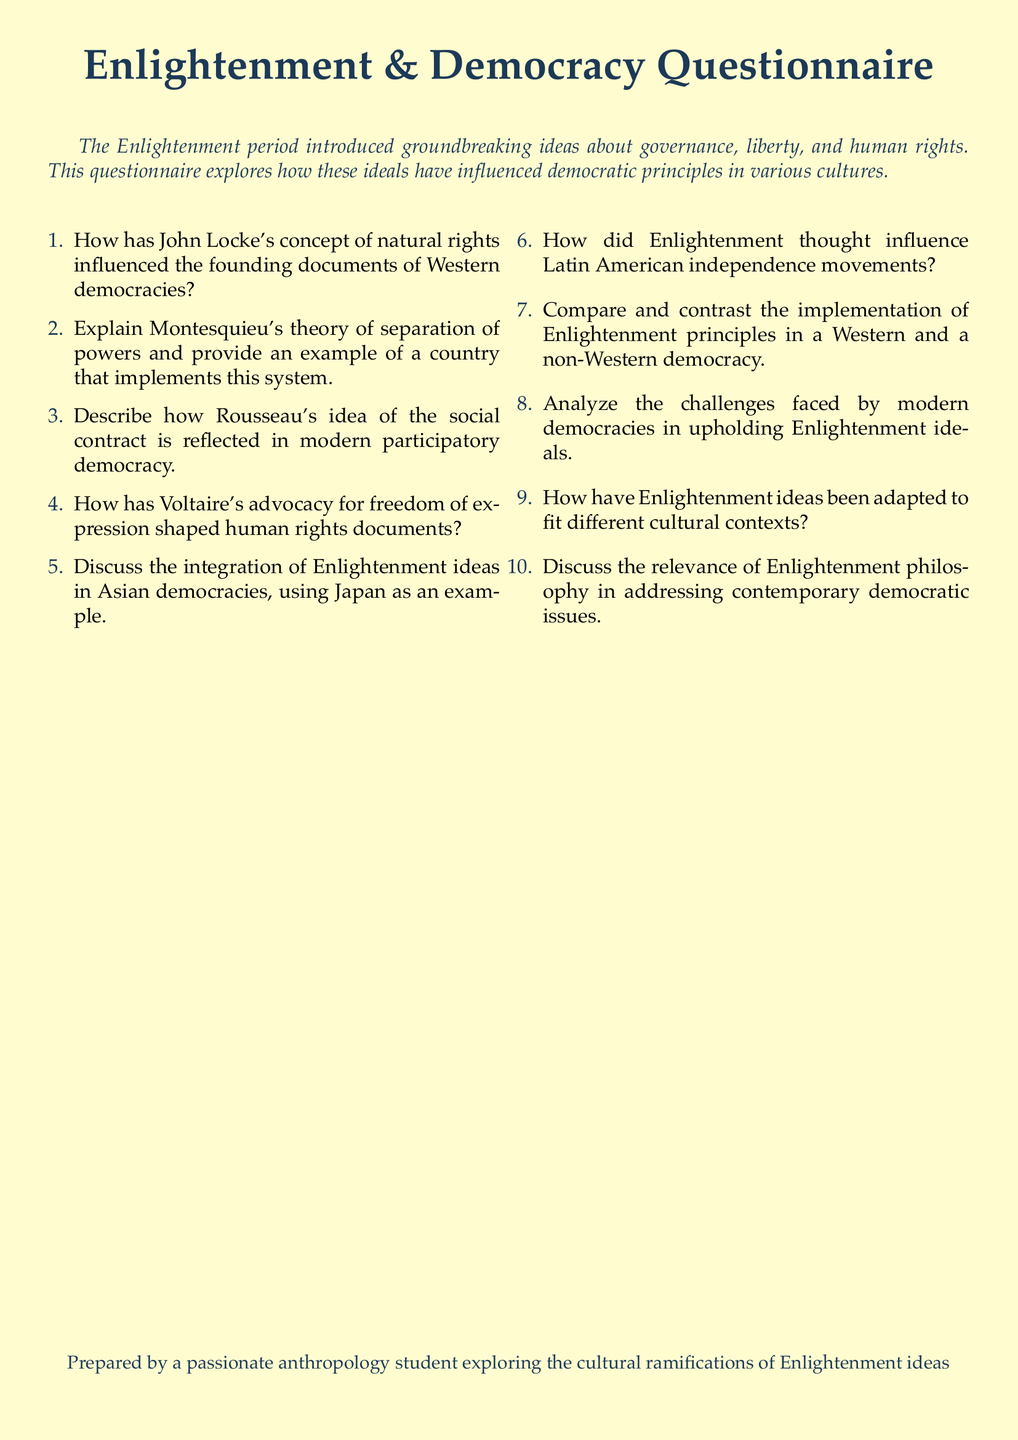What is the title of the document? The title of the document is prominently displayed at the top and indicates the focus of the content.
Answer: Enlightenment & Democracy Questionnaire How many questions are listed in the questionnaire? The number of questions can be counted in the enumerated list provided in the document.
Answer: 10 Who is the intended author of this questionnaire? The document contains a note at the bottom indicating the individual's role or identity related to the questionnaire.
Answer: a passionate anthropology student What philosophical concept is discussed in relation to John Locke? The document specifically mentions Locke's influential philosophical concept that underpins many democratic ideas.
Answer: natural rights Which document is mentioned as reflecting Rousseau's idea of social contract? The questionnaire asks for a modern democratic practice that embodies Rousseau’s political philosophy.
Answer: modern participatory democracy What color is used for the title text? The document states the specific color used in the title, showcasing the design aspect of the document.
Answer: enlightenmentblue What cultural context is provided as an example in question five? The questionnaire discusses the integration of Enlightenment ideas specifically within an Asian culture.
Answer: Japan Which Enlightenment thinker is associated with freedom of expression? The document attributes advocacy for a specific right to a key Enlightenment figure.
Answer: Voltaire What is the primary focus of this questionnaire? The introductory text clearly states the main theme and purpose of creating this document.
Answer: Enlightenment ideas' influence on democratic principles in various cultures 